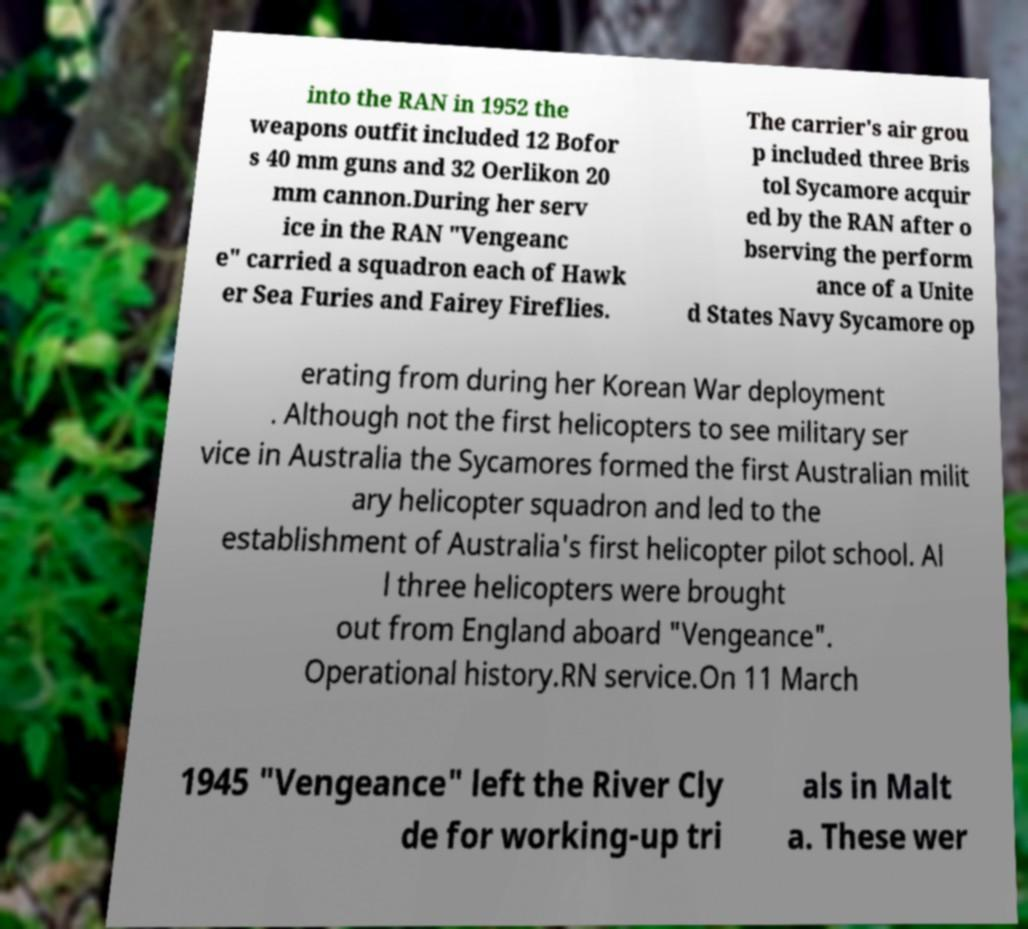Could you extract and type out the text from this image? into the RAN in 1952 the weapons outfit included 12 Bofor s 40 mm guns and 32 Oerlikon 20 mm cannon.During her serv ice in the RAN "Vengeanc e" carried a squadron each of Hawk er Sea Furies and Fairey Fireflies. The carrier's air grou p included three Bris tol Sycamore acquir ed by the RAN after o bserving the perform ance of a Unite d States Navy Sycamore op erating from during her Korean War deployment . Although not the first helicopters to see military ser vice in Australia the Sycamores formed the first Australian milit ary helicopter squadron and led to the establishment of Australia's first helicopter pilot school. Al l three helicopters were brought out from England aboard "Vengeance". Operational history.RN service.On 11 March 1945 "Vengeance" left the River Cly de for working-up tri als in Malt a. These wer 